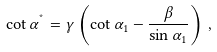Convert formula to latex. <formula><loc_0><loc_0><loc_500><loc_500>\cot \alpha ^ { ^ { * } } = \gamma \left ( \cot \alpha _ { 1 } - \frac { \beta } { \sin \alpha _ { 1 } } \right ) \, ,</formula> 